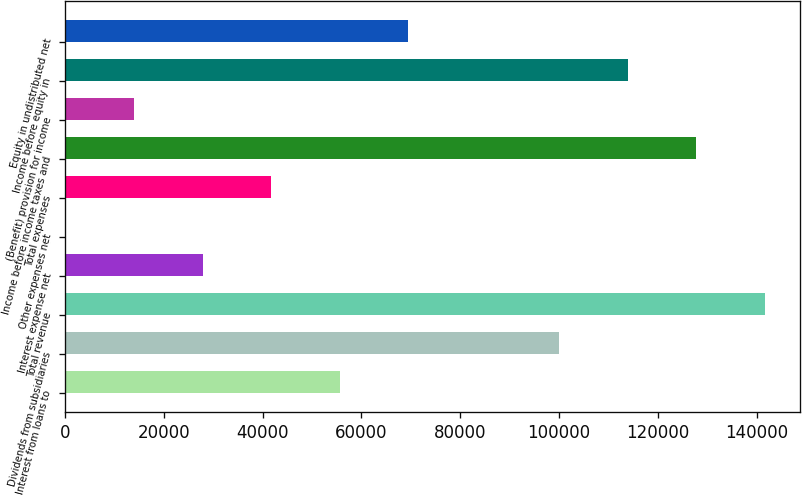<chart> <loc_0><loc_0><loc_500><loc_500><bar_chart><fcel>Interest from loans to<fcel>Dividends from subsidiaries<fcel>Total revenue<fcel>Interest expense net<fcel>Other expenses net<fcel>Total expenses<fcel>Income before income taxes and<fcel>(Benefit) provision for income<fcel>Income before equity in<fcel>Equity in undistributed net<nl><fcel>55582<fcel>100000<fcel>141582<fcel>27861<fcel>140<fcel>41721.5<fcel>127721<fcel>14000.5<fcel>113860<fcel>69442.5<nl></chart> 